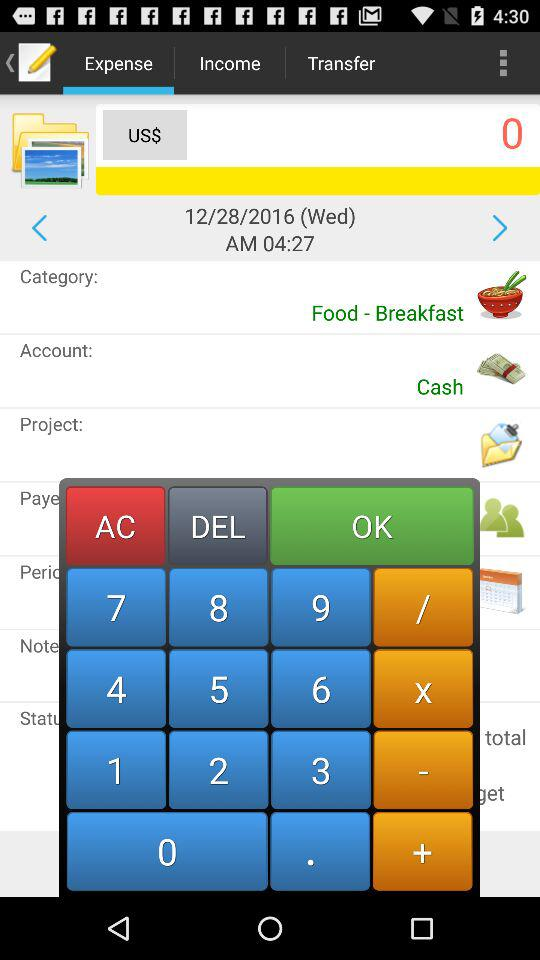Which tab is selected? The selected tab is "Expense". 